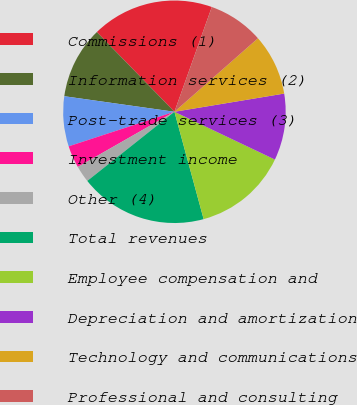Convert chart. <chart><loc_0><loc_0><loc_500><loc_500><pie_chart><fcel>Commissions (1)<fcel>Information services (2)<fcel>Post-trade services (3)<fcel>Investment income<fcel>Other (4)<fcel>Total revenues<fcel>Employee compensation and<fcel>Depreciation and amortization<fcel>Technology and communications<fcel>Professional and consulting<nl><fcel>17.74%<fcel>10.48%<fcel>7.26%<fcel>3.23%<fcel>2.42%<fcel>18.55%<fcel>13.71%<fcel>9.68%<fcel>8.87%<fcel>8.06%<nl></chart> 